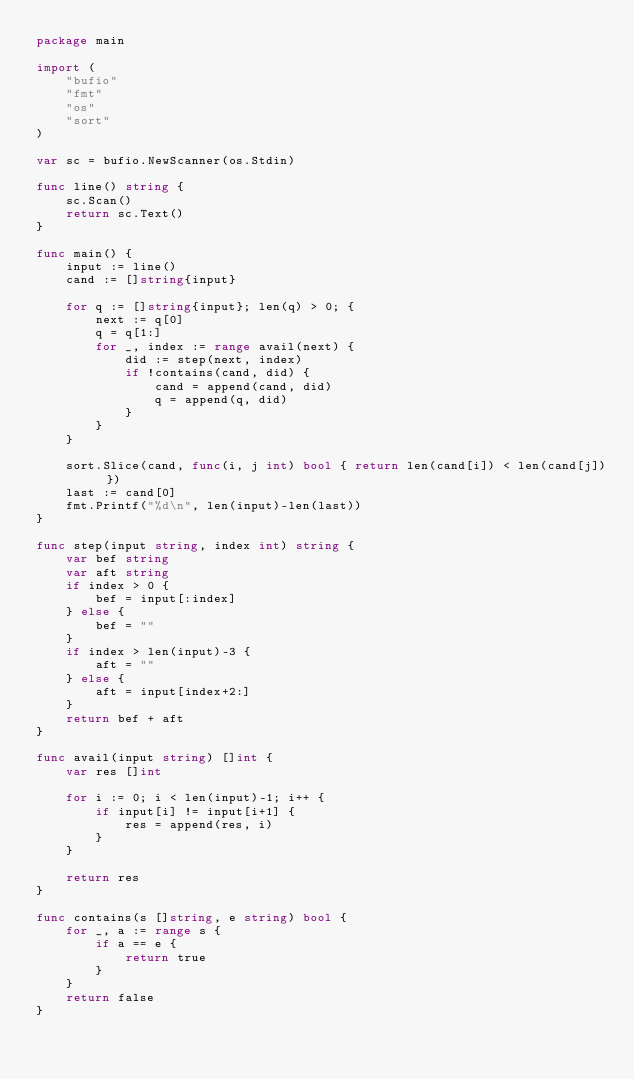Convert code to text. <code><loc_0><loc_0><loc_500><loc_500><_Go_>package main

import (
	"bufio"
	"fmt"
	"os"
	"sort"
)

var sc = bufio.NewScanner(os.Stdin)

func line() string {
	sc.Scan()
	return sc.Text()
}

func main() {
	input := line()
	cand := []string{input}

	for q := []string{input}; len(q) > 0; {
		next := q[0]
		q = q[1:]
		for _, index := range avail(next) {
			did := step(next, index)
			if !contains(cand, did) {
				cand = append(cand, did)
				q = append(q, did)
			}
		}
	}

	sort.Slice(cand, func(i, j int) bool { return len(cand[i]) < len(cand[j]) })
	last := cand[0]
	fmt.Printf("%d\n", len(input)-len(last))
}

func step(input string, index int) string {
	var bef string
	var aft string
	if index > 0 {
		bef = input[:index]
	} else {
		bef = ""
	}
	if index > len(input)-3 {
		aft = ""
	} else {
		aft = input[index+2:]
	}
	return bef + aft
}

func avail(input string) []int {
	var res []int

	for i := 0; i < len(input)-1; i++ {
		if input[i] != input[i+1] {
			res = append(res, i)
		}
	}

	return res
}

func contains(s []string, e string) bool {
	for _, a := range s {
		if a == e {
			return true
		}
	}
	return false
}
</code> 